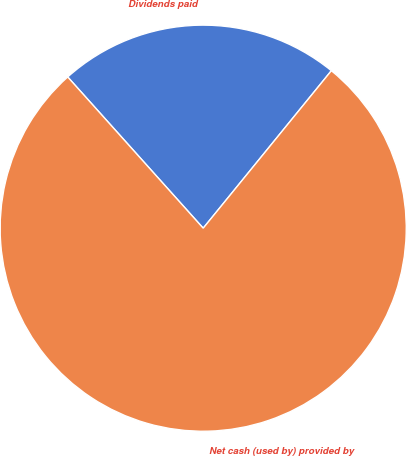Convert chart to OTSL. <chart><loc_0><loc_0><loc_500><loc_500><pie_chart><fcel>Dividends paid<fcel>Net cash (used by) provided by<nl><fcel>22.5%<fcel>77.5%<nl></chart> 